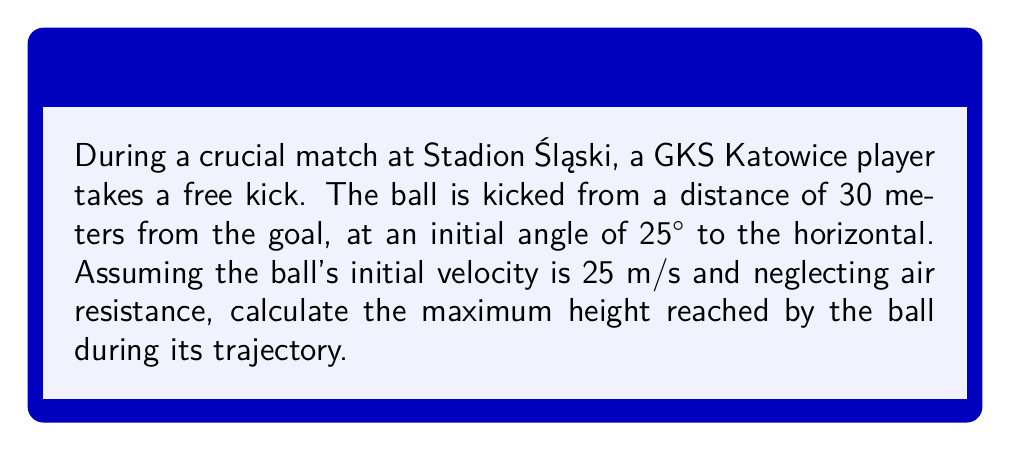Give your solution to this math problem. To solve this problem, we'll use trigonometric functions and the equations of projectile motion. Let's break it down step-by-step:

1) The maximum height of a projectile occurs at the highest point of its trajectory, where the vertical velocity becomes zero.

2) We can use the equation for the maximum height of a projectile:

   $$h_{max} = \frac{v_0^2 \sin^2 \theta}{2g}$$

   Where:
   $h_{max}$ is the maximum height
   $v_0$ is the initial velocity
   $\theta$ is the launch angle
   $g$ is the acceleration due to gravity (9.8 m/s²)

3) We're given:
   $v_0 = 25$ m/s
   $\theta = 25°$
   $g = 9.8$ m/s²

4) Let's substitute these values into our equation:

   $$h_{max} = \frac{(25)^2 \sin^2(25°)}{2(9.8)}$$

5) Now, let's calculate:
   
   $$h_{max} = \frac{625 \cdot (0.4226)^2}{19.6}$$
   
   $$h_{max} = \frac{625 \cdot 0.1786}{19.6}$$
   
   $$h_{max} = \frac{111.625}{19.6}$$
   
   $$h_{max} = 5.69$$ meters

6) Rounding to two decimal places, we get 5.69 meters.
Answer: The maximum height reached by the ball is approximately 5.69 meters. 